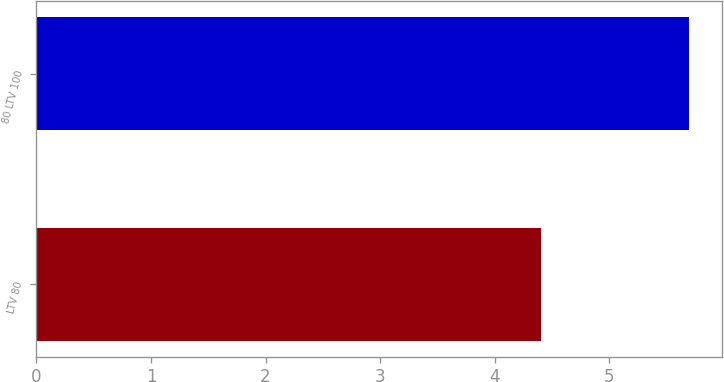<chart> <loc_0><loc_0><loc_500><loc_500><bar_chart><fcel>LTV 80<fcel>80 LTV 100<nl><fcel>4.4<fcel>5.7<nl></chart> 